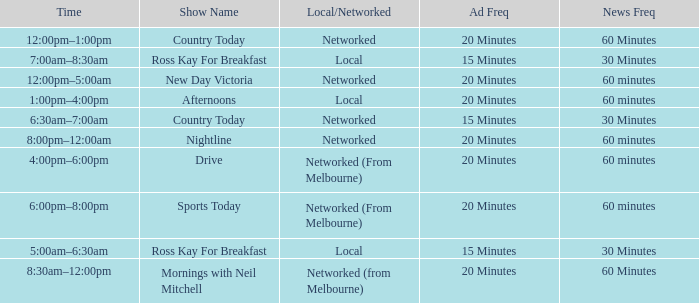What Time has a Show Name of mornings with neil mitchell? 8:30am–12:00pm. 